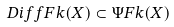<formula> <loc_0><loc_0><loc_500><loc_500>\ D i f f F k ( X ) \subset \Psi F k ( X )</formula> 